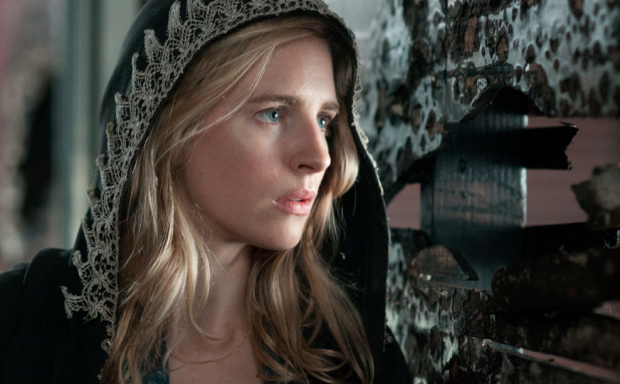Describe how a soundtrack might enhance the mood of this scene. A carefully chosen soundtrack could greatly enhance the mood of this scene. A haunting, somber melody with low tones and a gradual build-up would heighten the sense of tension and anticipation. The incorporation of subtle, eerie sounds, like whispers or distant echoes, would add to the mystery and suspense. As the character's expression shifts, the music could become more intense, reflecting her inner turmoil and the unfolding drama, ultimately immersing the viewer deeper into the narrative. What historical or cultural references could be present in this imagery? The imagery could be steeped in historical and cultural references. The character’s cloak and the background of peeling posters might evoke a sense of wartime resistance movements, reminiscent of World War II underground operations or dystopian societal struggles. The decayed setting might symbolize the fall of an empire or a post-apocalyptic world, drawing parallels to literature and films that explore themes of downfall and revolution. The intricate lace trim on the cloak adds a touch of historic elegance, possibly alluding to eras of aristocracy and the clash between old-world refinement and the harsh realities of survival. 